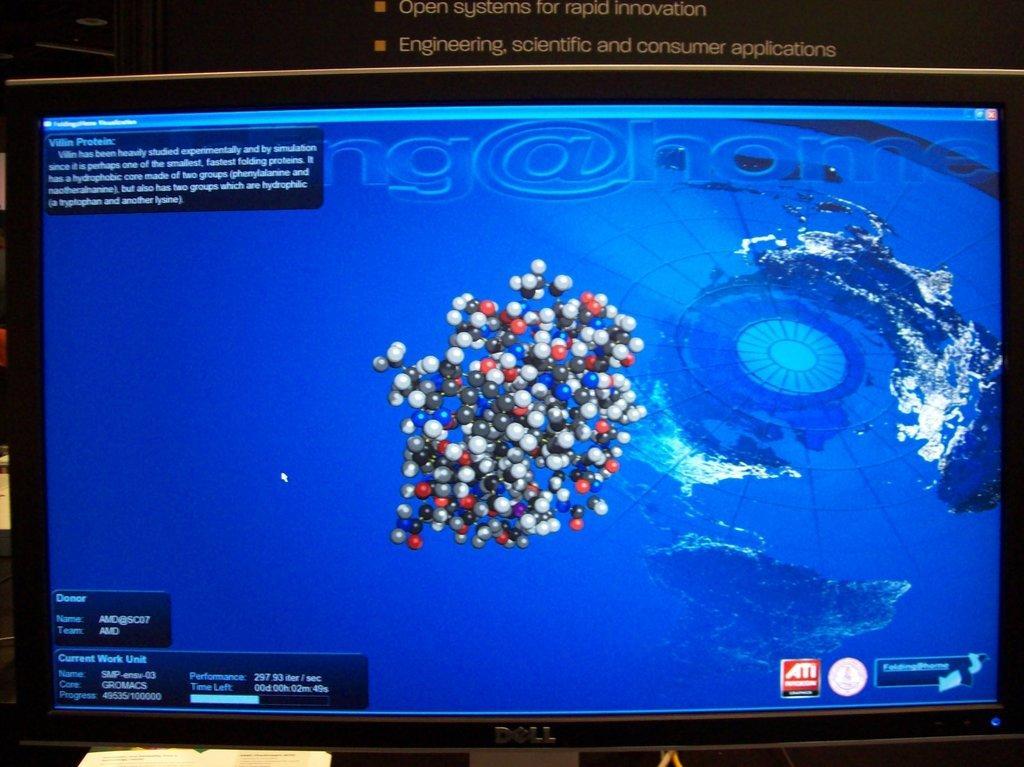In one or two sentences, can you explain what this image depicts? In this image we can see screen of a monitor. 